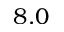Convert formula to latex. <formula><loc_0><loc_0><loc_500><loc_500>8 . 0</formula> 